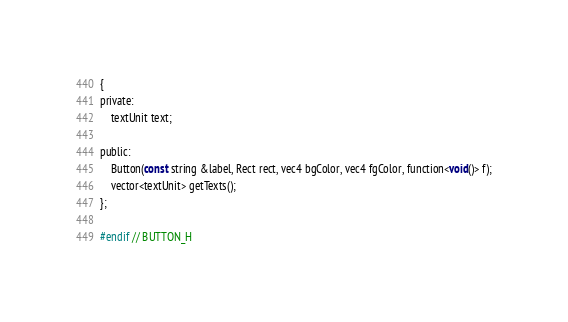<code> <loc_0><loc_0><loc_500><loc_500><_C_>{
private:
    textUnit text;

public:
    Button(const string &label, Rect rect, vec4 bgColor, vec4 fgColor, function<void()> f);
    vector<textUnit> getTexts();
};

#endif // BUTTON_H
</code> 